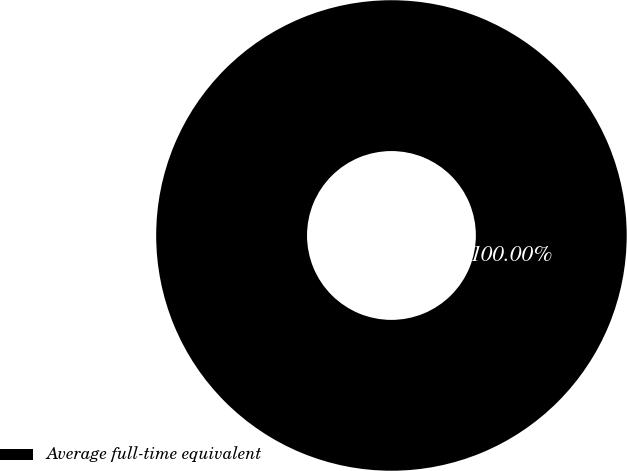Convert chart to OTSL. <chart><loc_0><loc_0><loc_500><loc_500><pie_chart><fcel>Average full-time equivalent<nl><fcel>100.0%<nl></chart> 